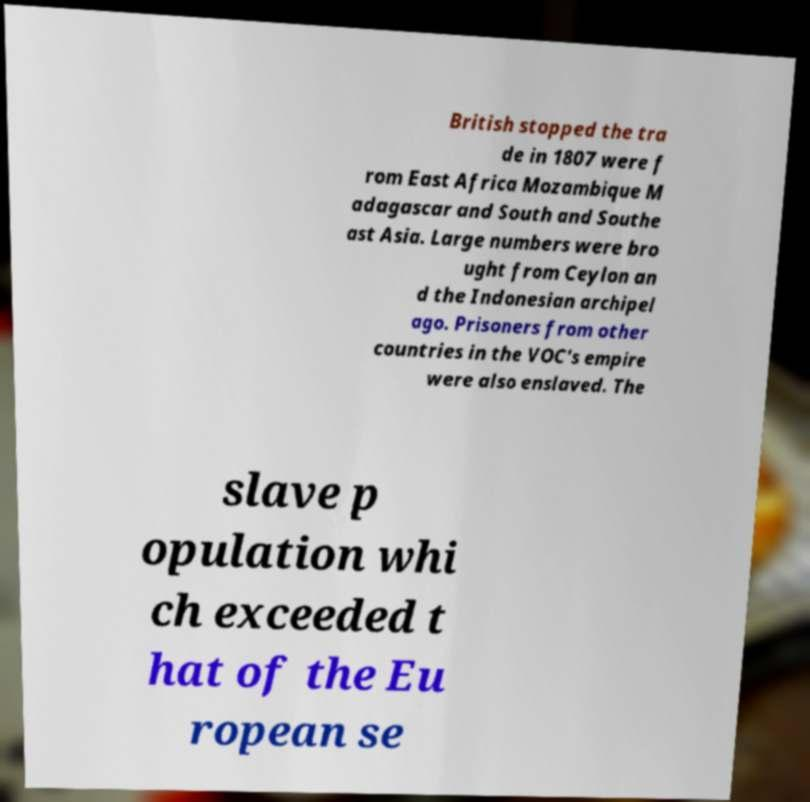I need the written content from this picture converted into text. Can you do that? British stopped the tra de in 1807 were f rom East Africa Mozambique M adagascar and South and Southe ast Asia. Large numbers were bro ught from Ceylon an d the Indonesian archipel ago. Prisoners from other countries in the VOC's empire were also enslaved. The slave p opulation whi ch exceeded t hat of the Eu ropean se 